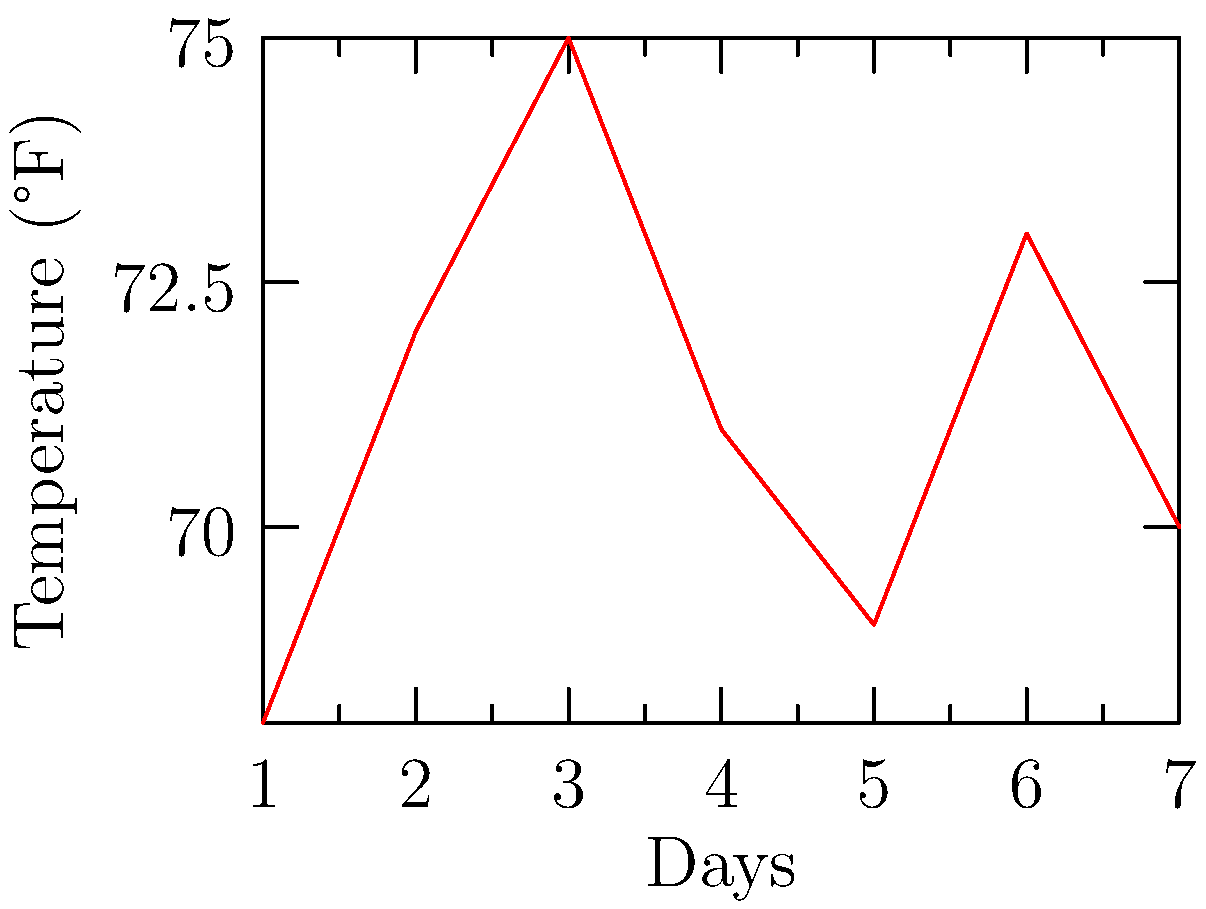Looking at the line graph showing temperature changes over a week, what was the highest temperature recorded? To find the highest temperature recorded, we need to follow these steps:

1. Look at the vertical axis (y-axis) of the graph, which shows the temperature in degrees Fahrenheit (°F).

2. Scan the red line on the graph, which represents the temperature changes over the week.

3. Find the highest point on the red line. This represents the day with the highest temperature.

4. The highest point appears to be on day 3 of the week.

5. Tracing this point to the y-axis, we can see that it corresponds to 75°F.

Therefore, the highest temperature recorded during the week was 75°F.
Answer: 75°F 